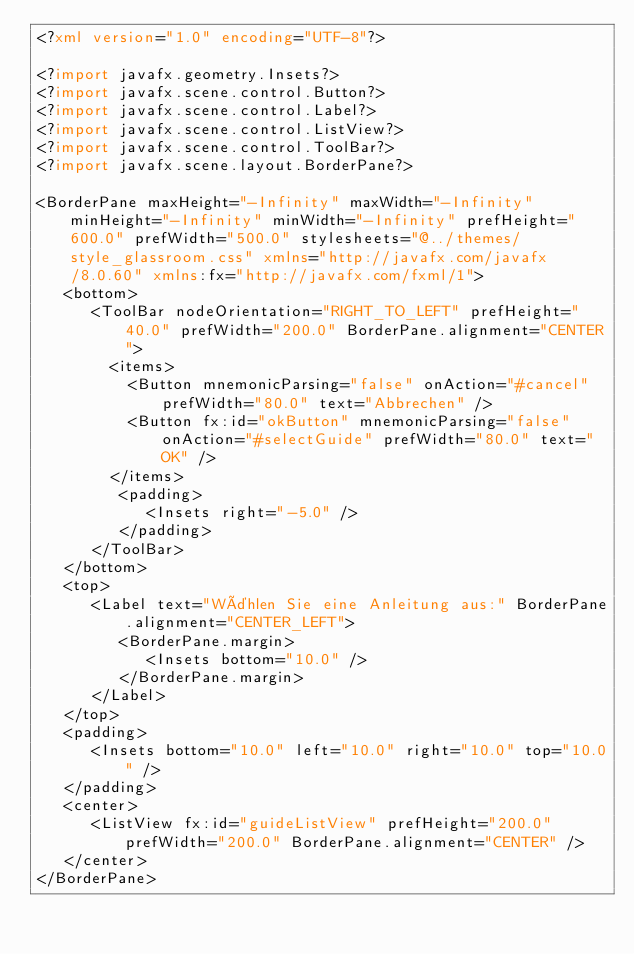<code> <loc_0><loc_0><loc_500><loc_500><_XML_><?xml version="1.0" encoding="UTF-8"?>

<?import javafx.geometry.Insets?>
<?import javafx.scene.control.Button?>
<?import javafx.scene.control.Label?>
<?import javafx.scene.control.ListView?>
<?import javafx.scene.control.ToolBar?>
<?import javafx.scene.layout.BorderPane?>

<BorderPane maxHeight="-Infinity" maxWidth="-Infinity" minHeight="-Infinity" minWidth="-Infinity" prefHeight="600.0" prefWidth="500.0" stylesheets="@../themes/style_glassroom.css" xmlns="http://javafx.com/javafx/8.0.60" xmlns:fx="http://javafx.com/fxml/1">
   <bottom>
      <ToolBar nodeOrientation="RIGHT_TO_LEFT" prefHeight="40.0" prefWidth="200.0" BorderPane.alignment="CENTER">
        <items>
          <Button mnemonicParsing="false" onAction="#cancel" prefWidth="80.0" text="Abbrechen" />
          <Button fx:id="okButton" mnemonicParsing="false" onAction="#selectGuide" prefWidth="80.0" text="OK" />
        </items>
         <padding>
            <Insets right="-5.0" />
         </padding>
      </ToolBar>
   </bottom>
   <top>
      <Label text="Wählen Sie eine Anleitung aus:" BorderPane.alignment="CENTER_LEFT">
         <BorderPane.margin>
            <Insets bottom="10.0" />
         </BorderPane.margin>
      </Label>
   </top>
   <padding>
      <Insets bottom="10.0" left="10.0" right="10.0" top="10.0" />
   </padding>
   <center>
      <ListView fx:id="guideListView" prefHeight="200.0" prefWidth="200.0" BorderPane.alignment="CENTER" />
   </center>
</BorderPane>
</code> 